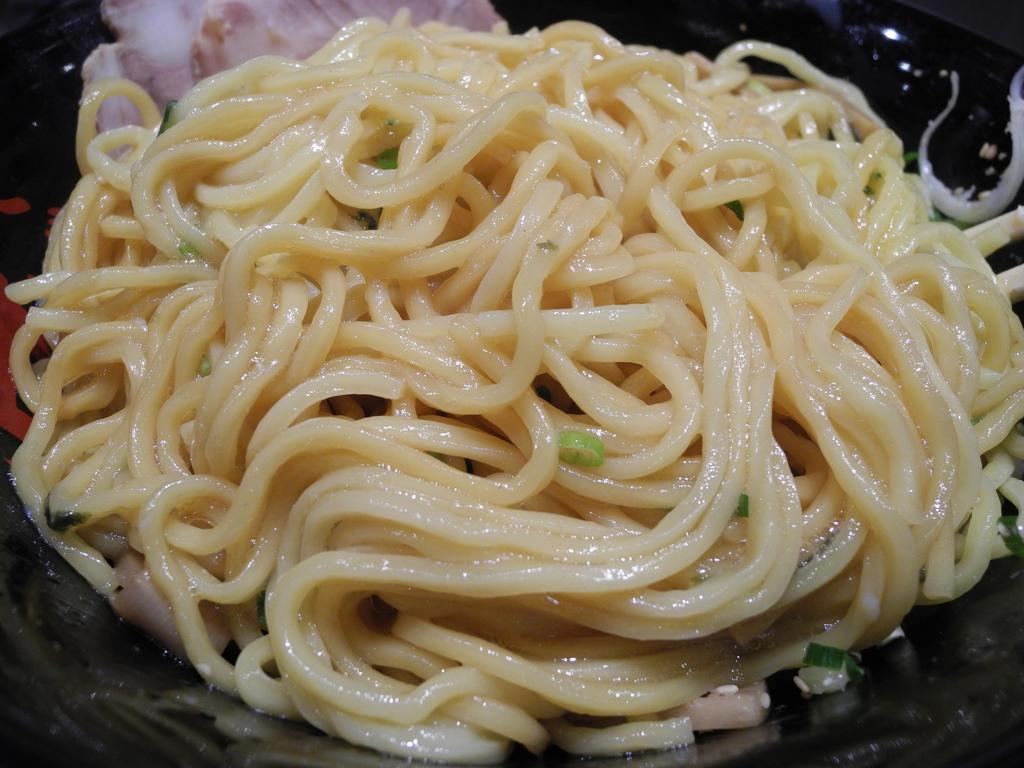What is the main subject of the image? The main subject of the image is a group of noodles in a bowl. Can you describe the contents of the bowl? The bowl contains a group of noodles. Is there anything else visible in the image besides the noodles? Yes, there is meat visible in the background of the image. What type of pump is being used to inflate the noodles in the image? There is no pump present in the image, and the noodles are not inflatable. 